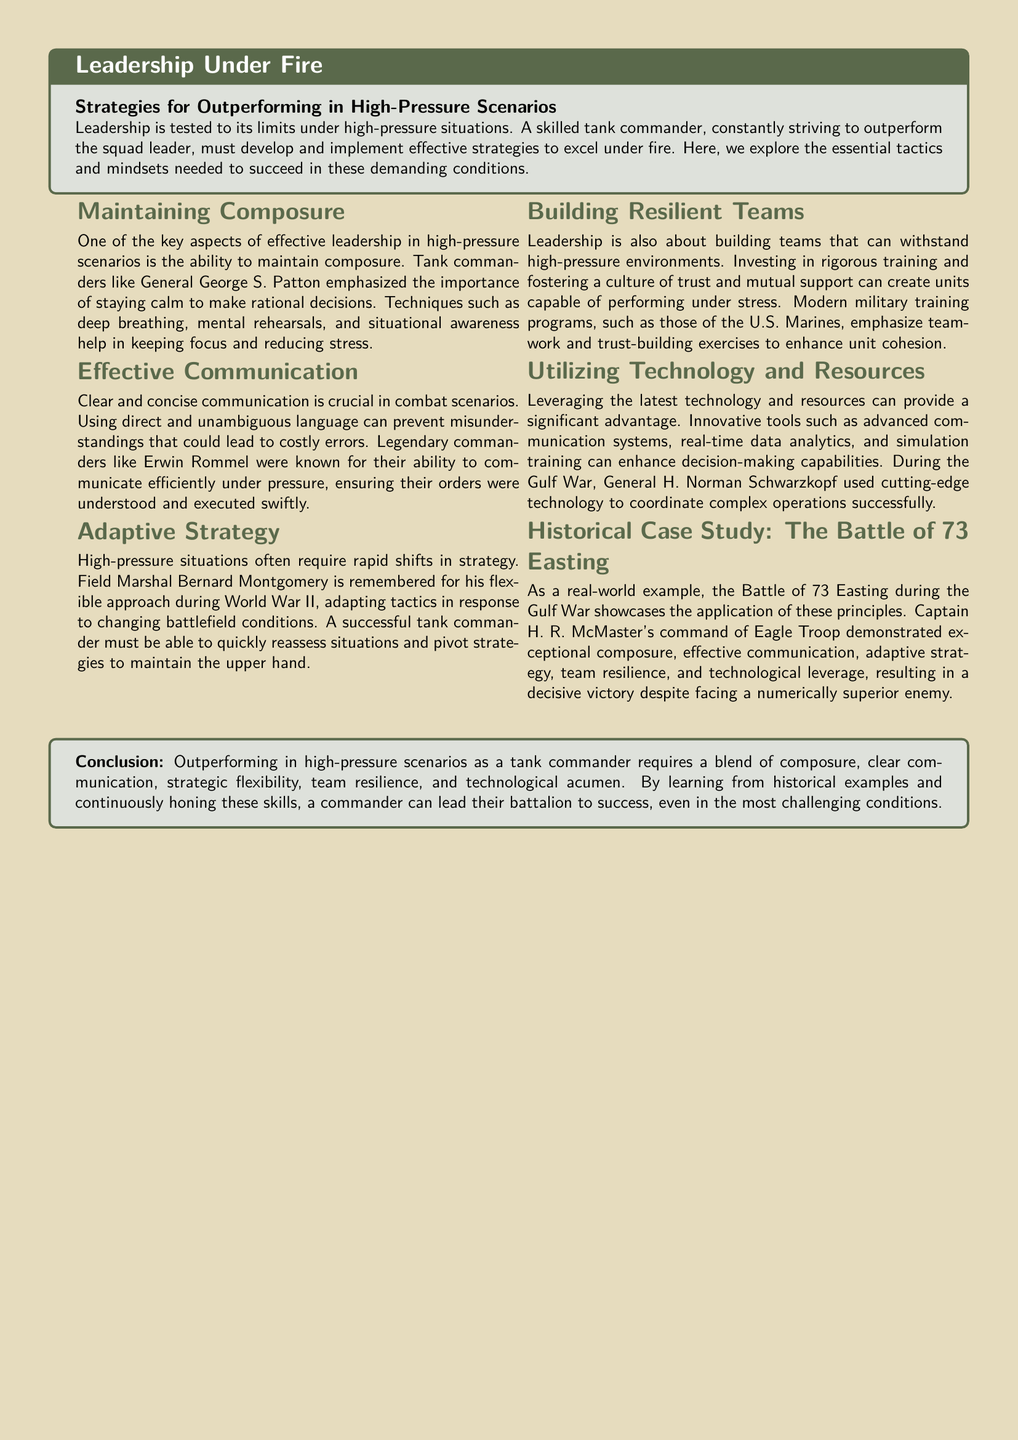What is the title of the document? The title of the document is prominently displayed at the top, specifying the main focus.
Answer: Leadership Under Fire Who is mentioned as a legendary commander known for efficient communication? The document highlights a specific historical figure recognized for communication skills under pressure.
Answer: Erwin Rommel What historical event is used as a case study in this document? A specific battle is referenced to illustrate the application of the discussed leadership principles.
Answer: The Battle of 73 Easting Which military leader emphasized the importance of maintaining composure? A specific general is highlighted in the context of maintaining calm during high-pressure scenarios.
Answer: General George S. Patton What approach did Field Marshal Bernard Montgomery exemplify? The document notes a particular leadership style that involves responding to battlefield changes.
Answer: Adaptive strategy What is one of the strategies for building resilient teams? A key tactic for leadership in stressful environments is mentioned regarding team cohesion.
Answer: Trust and mutual support What technological advantage is described in relation to General H. Norman Schwarzkopf? The document focuses on the tools and resources utilized to enhance military operations.
Answer: Advanced communication systems What mindset should a tank commander have under pressure? The document suggests a specific mental approach to ensure effective leadership in challenging situations.
Answer: Composure What type of training is emphasized in modern military programs? The document outlines the focus of training programs designed to strengthen unit performance.
Answer: Teamwork and trust-building exercises 